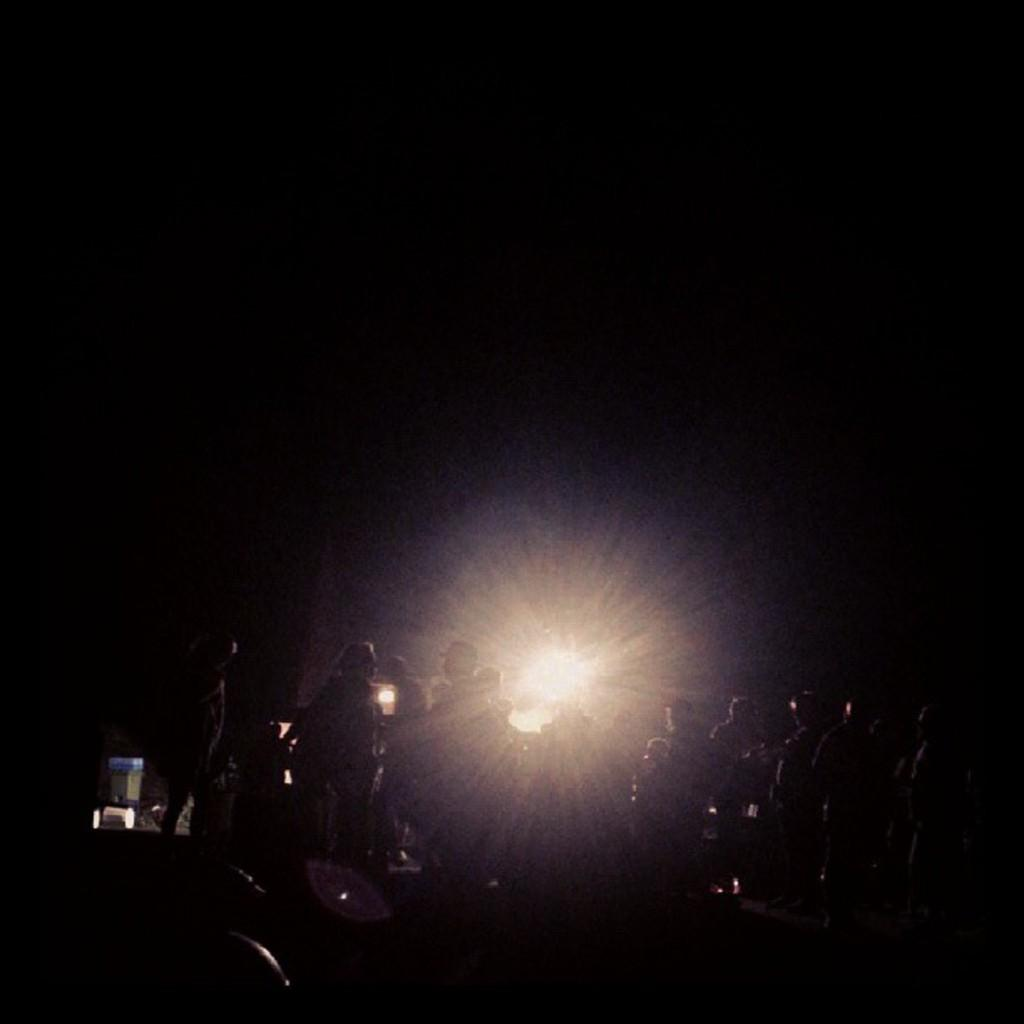What is the overall lighting condition in the image? The image is dark. Can you describe the people in the image? There is a group of people gathered in the image. What is the source of light behind the group of people? There is a huge spotlight behind the group of people. What type of bun is being served at the event in the image? There is no event or bun present in the image; it only shows a group of people and a spotlight. How does the development of the group of people in the image contribute to their success? There is no information about the development or success of the group of people in the image, as it only shows them gathered with a spotlight behind them. 